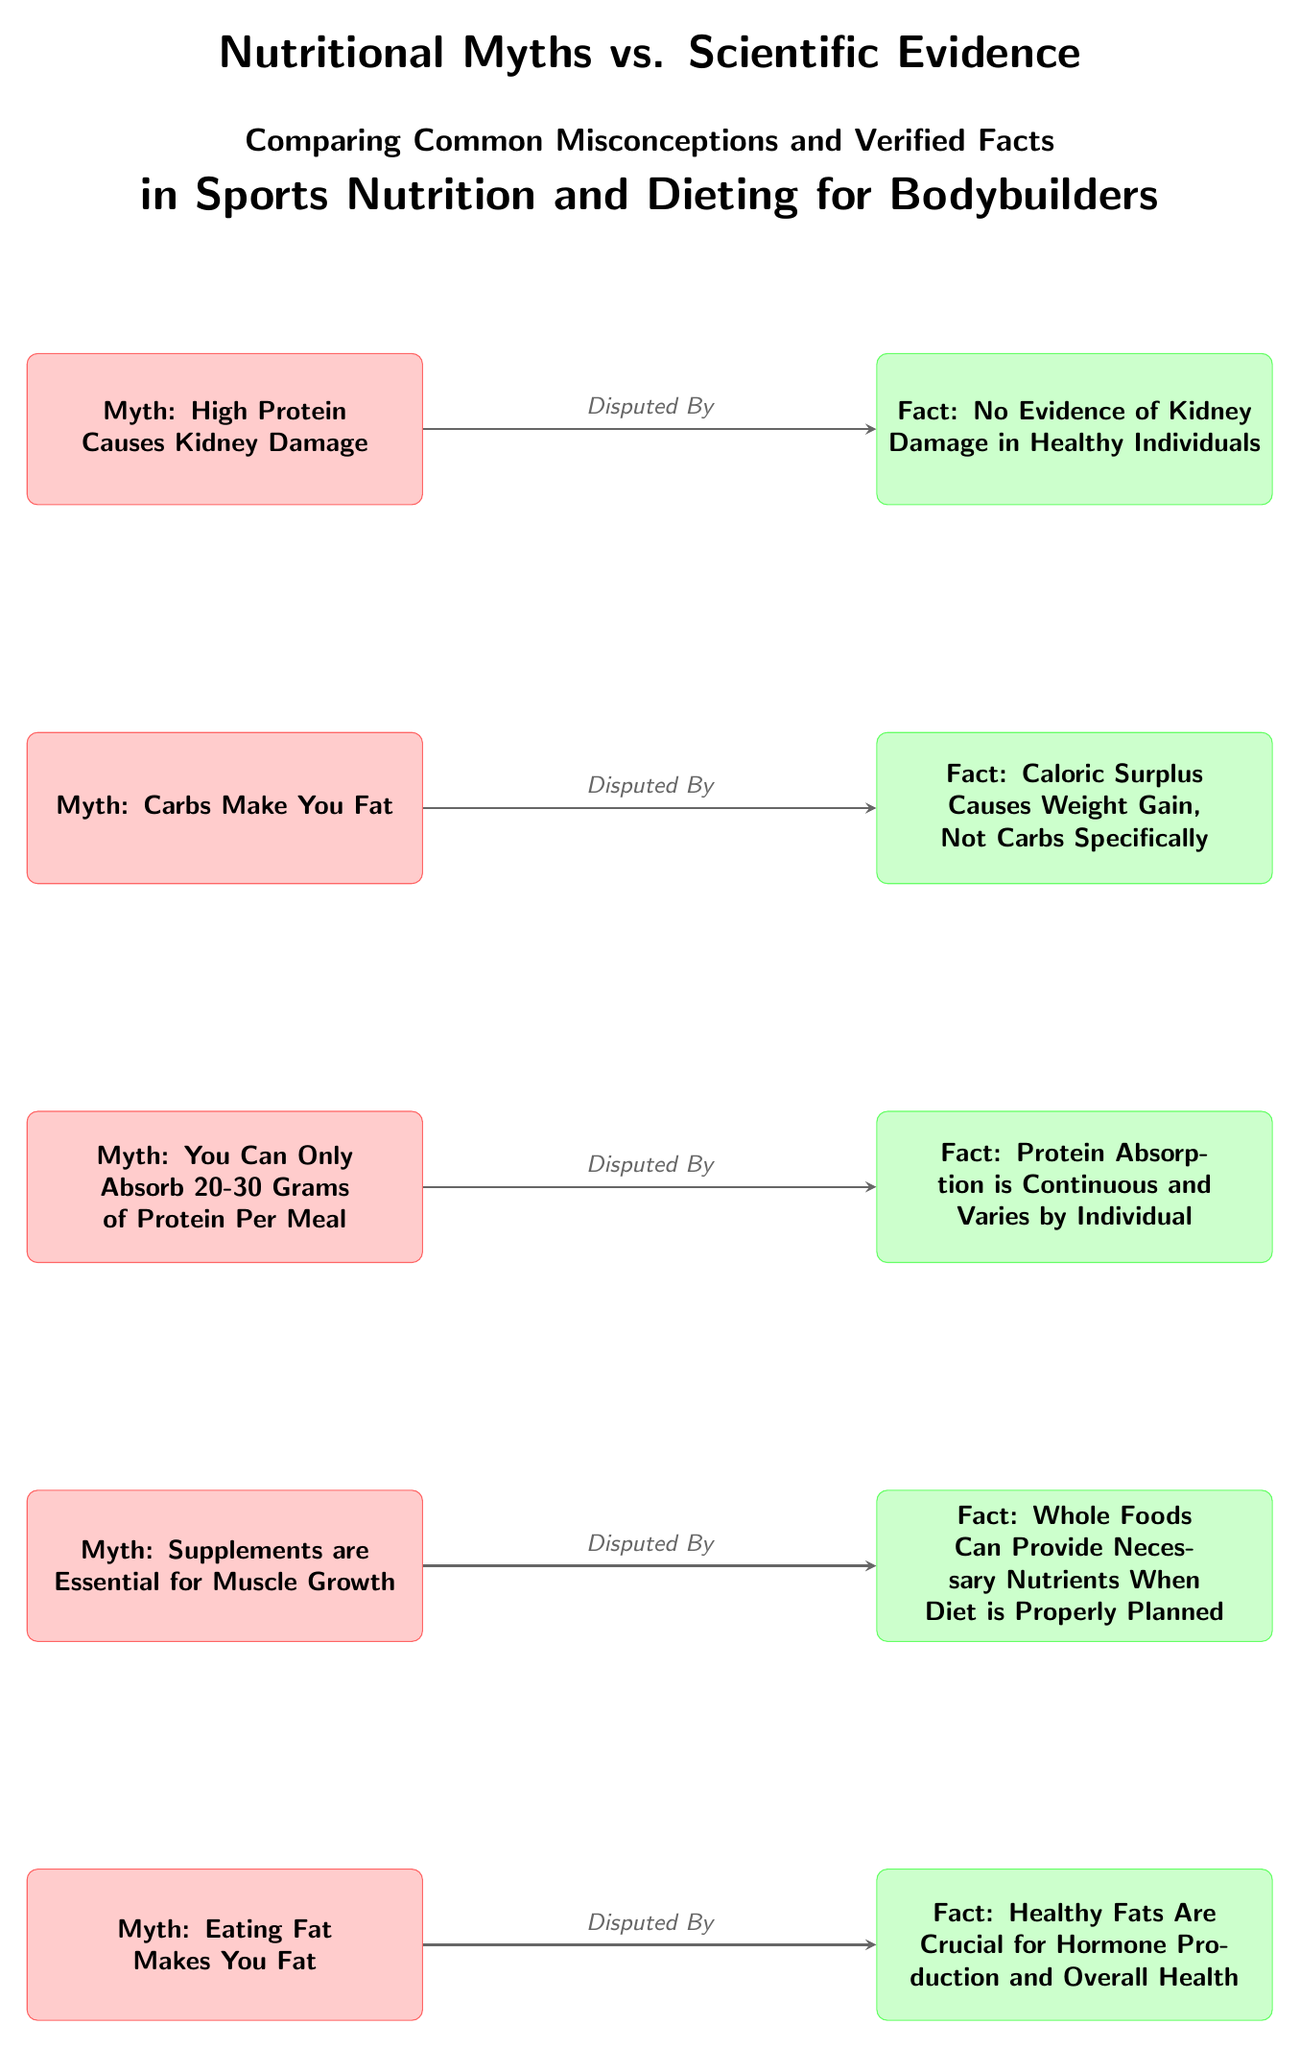What is the first myth listed in the diagram? The diagram presents the myths in a vertical alignment, with the first myth positioned at the top. Looking at the nodes, the first myth reads "High Protein Causes Kidney Damage."
Answer: High Protein Causes Kidney Damage How many myths are presented in the diagram? The diagram contains five myths listed vertically, with each myth connected to its corresponding fact. Thus, counting the nodes for the myths yields a total of five.
Answer: 5 What does the second fact argue about carbohydrates? The second fact connected to the myth about carbohydrates clearly states, "Caloric Surplus Causes Weight Gain, Not Carbs Specifically." This indicates that the fact disputes the idea that carbs alone contribute to weight gain.
Answer: Caloric Surplus Causes Weight Gain, Not Carbs Specifically Which myth is disputed by the fact that "Whole Foods Can Provide Necessary Nutrients When Diet is Properly Planned"? The fact stating "Whole Foods Can Provide Necessary Nutrients When Diet is Properly Planned" directly disputes the myth that "Supplements are Essential for Muscle Growth," as it promotes the idea that a well-planned diet can replace the need for supplements.
Answer: Supplements are Essential for Muscle Growth What relationship do all myths have with their respective facts? Each myth is linked to its respective fact by an arrow labeled "Disputed By," indicating that the fact contradicts or offers a more scientifically backed perspective on the myth. As such, this structure signifies a clear contrast between myth and evidence.
Answer: Disputed By 